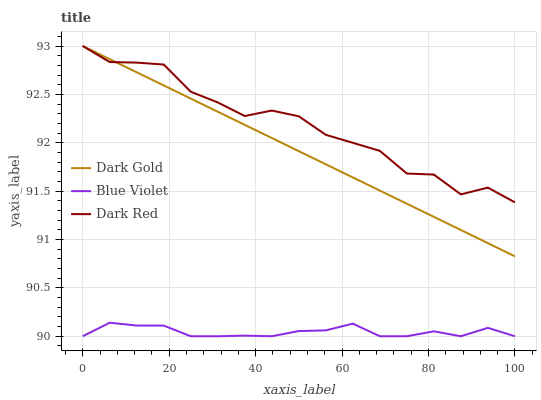Does Blue Violet have the minimum area under the curve?
Answer yes or no. Yes. Does Dark Red have the maximum area under the curve?
Answer yes or no. Yes. Does Dark Gold have the minimum area under the curve?
Answer yes or no. No. Does Dark Gold have the maximum area under the curve?
Answer yes or no. No. Is Dark Gold the smoothest?
Answer yes or no. Yes. Is Dark Red the roughest?
Answer yes or no. Yes. Is Blue Violet the smoothest?
Answer yes or no. No. Is Blue Violet the roughest?
Answer yes or no. No. Does Blue Violet have the lowest value?
Answer yes or no. Yes. Does Dark Gold have the lowest value?
Answer yes or no. No. Does Dark Gold have the highest value?
Answer yes or no. Yes. Does Blue Violet have the highest value?
Answer yes or no. No. Is Blue Violet less than Dark Gold?
Answer yes or no. Yes. Is Dark Gold greater than Blue Violet?
Answer yes or no. Yes. Does Dark Red intersect Dark Gold?
Answer yes or no. Yes. Is Dark Red less than Dark Gold?
Answer yes or no. No. Is Dark Red greater than Dark Gold?
Answer yes or no. No. Does Blue Violet intersect Dark Gold?
Answer yes or no. No. 